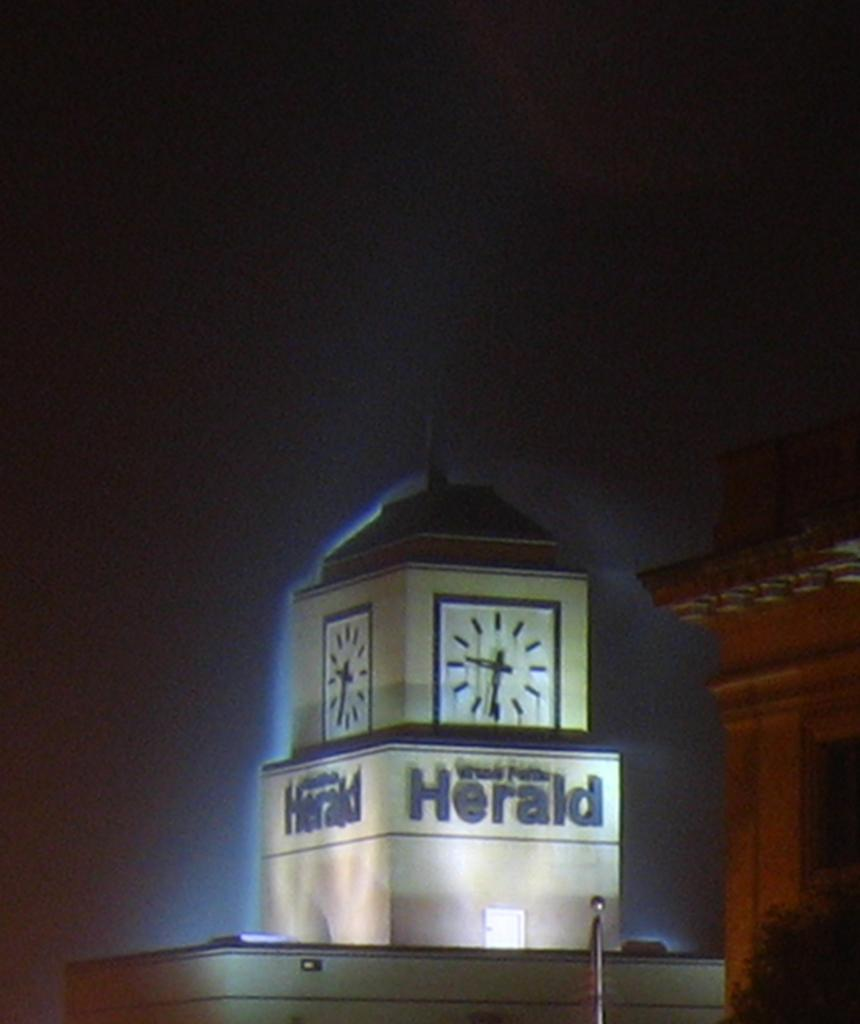<image>
Render a clear and concise summary of the photo. The tower at the Herald has a clock on the top. 